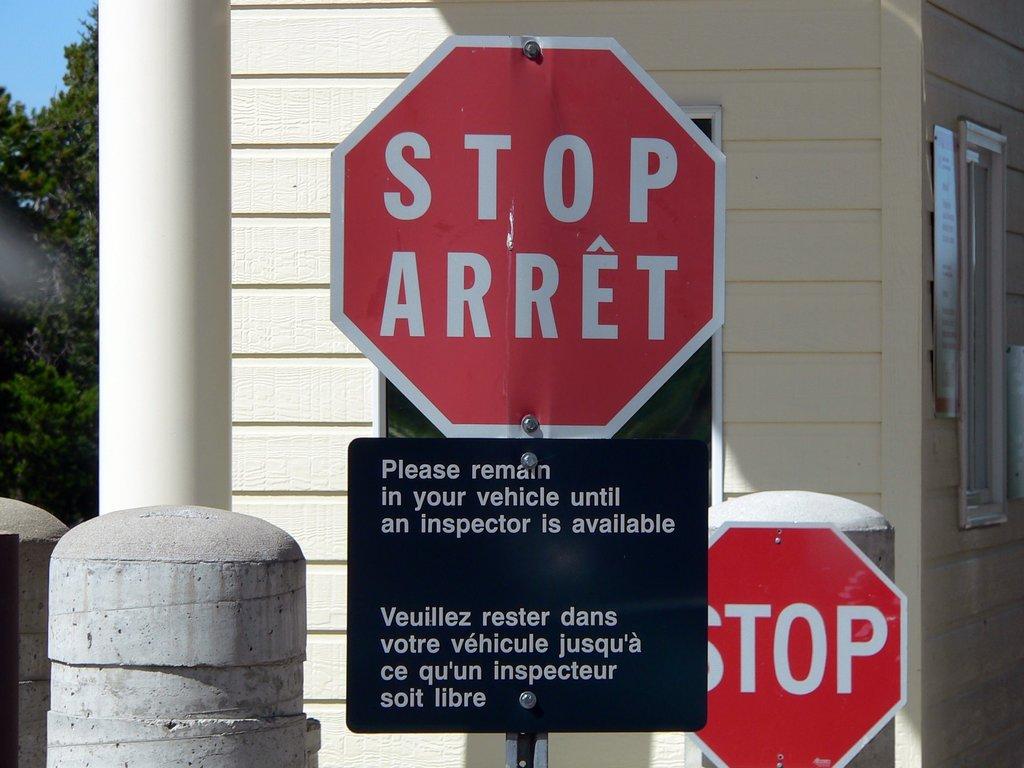What street sign is shown here?
Keep it short and to the point. Stop. 